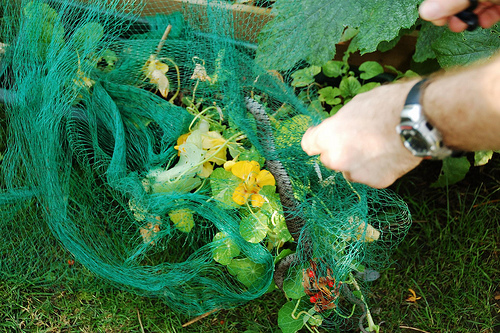<image>
Can you confirm if the netting is in front of the flower? Yes. The netting is positioned in front of the flower, appearing closer to the camera viewpoint. 